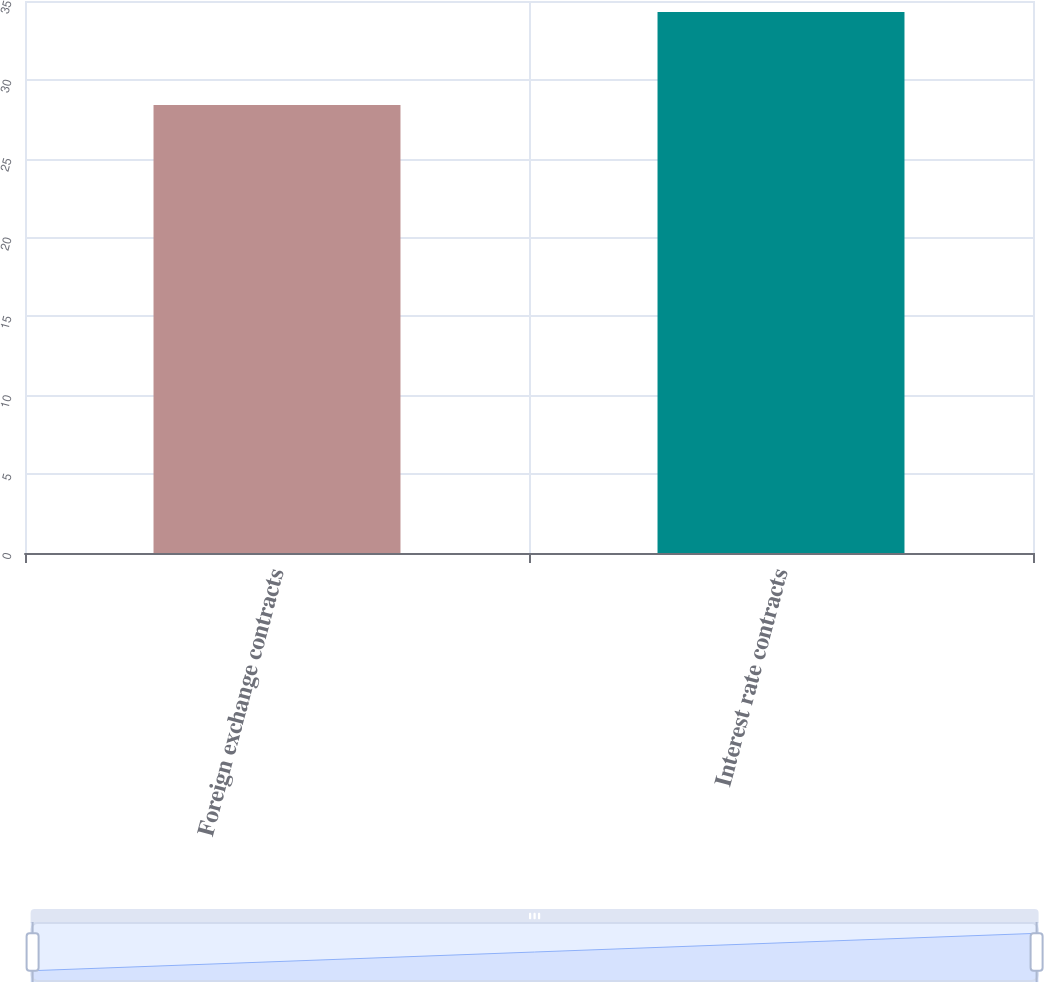Convert chart to OTSL. <chart><loc_0><loc_0><loc_500><loc_500><bar_chart><fcel>Foreign exchange contracts<fcel>Interest rate contracts<nl><fcel>28.4<fcel>34.3<nl></chart> 